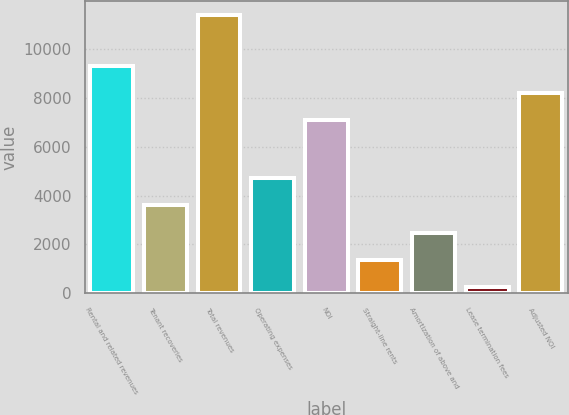Convert chart to OTSL. <chart><loc_0><loc_0><loc_500><loc_500><bar_chart><fcel>Rental and related revenues<fcel>Tenant recoveries<fcel>Total revenues<fcel>Operating expenses<fcel>NOI<fcel>Straight-line rents<fcel>Amortization of above and<fcel>Lease termination fees<fcel>Adjusted NOI<nl><fcel>9311.6<fcel>3595.9<fcel>11389<fcel>4709.2<fcel>7085<fcel>1369.3<fcel>2482.6<fcel>256<fcel>8198.3<nl></chart> 